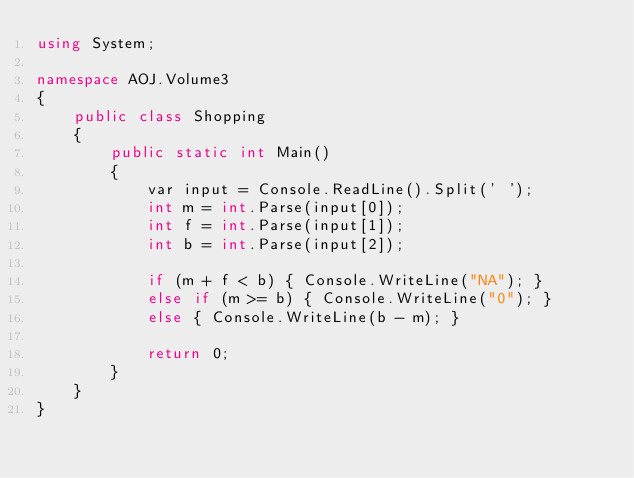Convert code to text. <code><loc_0><loc_0><loc_500><loc_500><_C#_>using System;

namespace AOJ.Volume3
{
    public class Shopping
    {
        public static int Main()
        {
            var input = Console.ReadLine().Split(' ');
            int m = int.Parse(input[0]);
            int f = int.Parse(input[1]);
            int b = int.Parse(input[2]);

            if (m + f < b) { Console.WriteLine("NA"); }
            else if (m >= b) { Console.WriteLine("0"); }
            else { Console.WriteLine(b - m); }

            return 0;
        }
    }
}</code> 